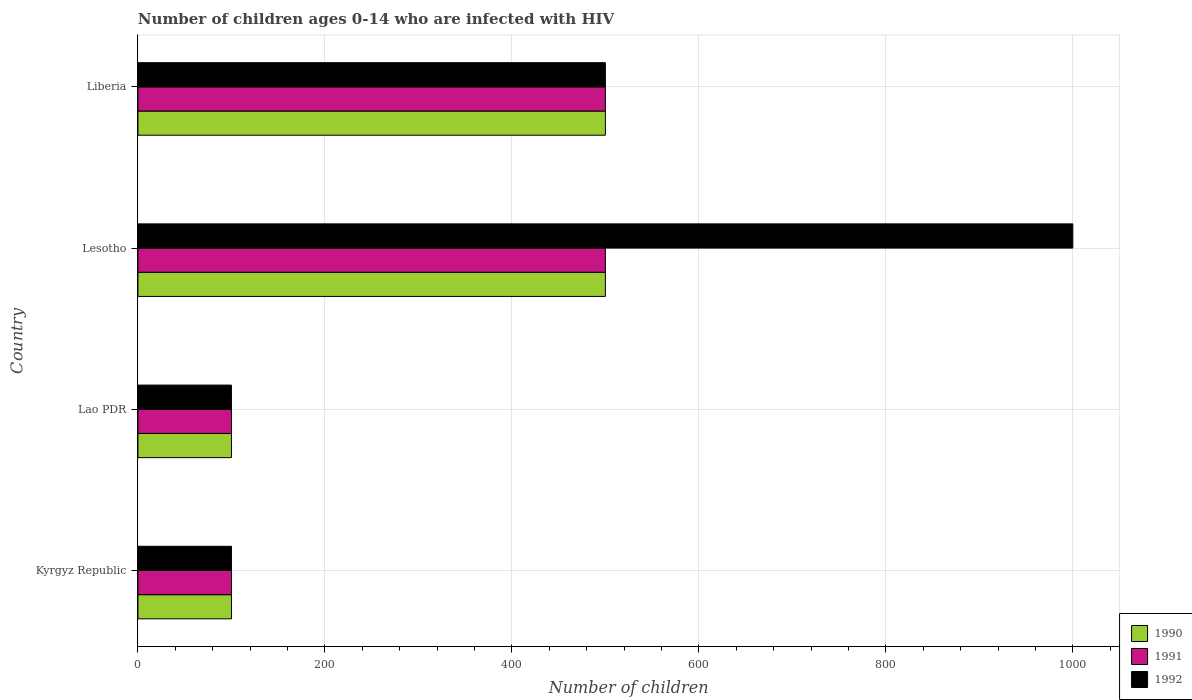How many different coloured bars are there?
Ensure brevity in your answer.  3. How many bars are there on the 2nd tick from the top?
Keep it short and to the point. 3. How many bars are there on the 2nd tick from the bottom?
Ensure brevity in your answer.  3. What is the label of the 1st group of bars from the top?
Ensure brevity in your answer.  Liberia. In how many cases, is the number of bars for a given country not equal to the number of legend labels?
Your answer should be compact. 0. What is the number of HIV infected children in 1990 in Kyrgyz Republic?
Your response must be concise. 100. Across all countries, what is the maximum number of HIV infected children in 1990?
Your answer should be very brief. 500. Across all countries, what is the minimum number of HIV infected children in 1992?
Give a very brief answer. 100. In which country was the number of HIV infected children in 1990 maximum?
Your answer should be very brief. Lesotho. In which country was the number of HIV infected children in 1991 minimum?
Make the answer very short. Kyrgyz Republic. What is the total number of HIV infected children in 1991 in the graph?
Give a very brief answer. 1200. What is the difference between the number of HIV infected children in 1992 in Kyrgyz Republic and that in Lao PDR?
Your answer should be very brief. 0. What is the difference between the number of HIV infected children in 1990 in Liberia and the number of HIV infected children in 1991 in Kyrgyz Republic?
Offer a terse response. 400. What is the average number of HIV infected children in 1992 per country?
Ensure brevity in your answer.  425. What is the difference between the number of HIV infected children in 1992 and number of HIV infected children in 1990 in Kyrgyz Republic?
Offer a very short reply. 0. What is the ratio of the number of HIV infected children in 1991 in Kyrgyz Republic to that in Liberia?
Offer a terse response. 0.2. What is the difference between the highest and the lowest number of HIV infected children in 1991?
Offer a terse response. 400. Is the sum of the number of HIV infected children in 1990 in Kyrgyz Republic and Lesotho greater than the maximum number of HIV infected children in 1991 across all countries?
Provide a succinct answer. Yes. Is it the case that in every country, the sum of the number of HIV infected children in 1992 and number of HIV infected children in 1990 is greater than the number of HIV infected children in 1991?
Your answer should be compact. Yes. Are all the bars in the graph horizontal?
Provide a short and direct response. Yes. How many countries are there in the graph?
Your response must be concise. 4. What is the difference between two consecutive major ticks on the X-axis?
Your answer should be compact. 200. Does the graph contain grids?
Your answer should be very brief. Yes. Where does the legend appear in the graph?
Your answer should be very brief. Bottom right. How many legend labels are there?
Provide a succinct answer. 3. What is the title of the graph?
Your answer should be compact. Number of children ages 0-14 who are infected with HIV. What is the label or title of the X-axis?
Your answer should be very brief. Number of children. What is the Number of children in 1990 in Kyrgyz Republic?
Ensure brevity in your answer.  100. What is the Number of children in 1990 in Lao PDR?
Offer a terse response. 100. What is the Number of children of 1992 in Lao PDR?
Provide a short and direct response. 100. What is the Number of children in 1990 in Lesotho?
Your response must be concise. 500. What is the Number of children in 1990 in Liberia?
Your response must be concise. 500. What is the Number of children of 1992 in Liberia?
Your answer should be very brief. 500. Across all countries, what is the maximum Number of children in 1991?
Offer a terse response. 500. Across all countries, what is the maximum Number of children in 1992?
Your answer should be very brief. 1000. Across all countries, what is the minimum Number of children in 1991?
Provide a succinct answer. 100. Across all countries, what is the minimum Number of children in 1992?
Make the answer very short. 100. What is the total Number of children of 1990 in the graph?
Ensure brevity in your answer.  1200. What is the total Number of children in 1991 in the graph?
Provide a short and direct response. 1200. What is the total Number of children in 1992 in the graph?
Provide a short and direct response. 1700. What is the difference between the Number of children in 1990 in Kyrgyz Republic and that in Lesotho?
Provide a succinct answer. -400. What is the difference between the Number of children in 1991 in Kyrgyz Republic and that in Lesotho?
Make the answer very short. -400. What is the difference between the Number of children in 1992 in Kyrgyz Republic and that in Lesotho?
Provide a short and direct response. -900. What is the difference between the Number of children of 1990 in Kyrgyz Republic and that in Liberia?
Your response must be concise. -400. What is the difference between the Number of children in 1991 in Kyrgyz Republic and that in Liberia?
Keep it short and to the point. -400. What is the difference between the Number of children in 1992 in Kyrgyz Republic and that in Liberia?
Make the answer very short. -400. What is the difference between the Number of children of 1990 in Lao PDR and that in Lesotho?
Provide a succinct answer. -400. What is the difference between the Number of children of 1991 in Lao PDR and that in Lesotho?
Your response must be concise. -400. What is the difference between the Number of children in 1992 in Lao PDR and that in Lesotho?
Offer a very short reply. -900. What is the difference between the Number of children of 1990 in Lao PDR and that in Liberia?
Your answer should be compact. -400. What is the difference between the Number of children of 1991 in Lao PDR and that in Liberia?
Give a very brief answer. -400. What is the difference between the Number of children in 1992 in Lao PDR and that in Liberia?
Ensure brevity in your answer.  -400. What is the difference between the Number of children in 1991 in Lesotho and that in Liberia?
Keep it short and to the point. 0. What is the difference between the Number of children in 1992 in Lesotho and that in Liberia?
Your response must be concise. 500. What is the difference between the Number of children of 1990 in Kyrgyz Republic and the Number of children of 1992 in Lao PDR?
Ensure brevity in your answer.  0. What is the difference between the Number of children in 1990 in Kyrgyz Republic and the Number of children in 1991 in Lesotho?
Keep it short and to the point. -400. What is the difference between the Number of children of 1990 in Kyrgyz Republic and the Number of children of 1992 in Lesotho?
Give a very brief answer. -900. What is the difference between the Number of children in 1991 in Kyrgyz Republic and the Number of children in 1992 in Lesotho?
Ensure brevity in your answer.  -900. What is the difference between the Number of children of 1990 in Kyrgyz Republic and the Number of children of 1991 in Liberia?
Provide a succinct answer. -400. What is the difference between the Number of children in 1990 in Kyrgyz Republic and the Number of children in 1992 in Liberia?
Ensure brevity in your answer.  -400. What is the difference between the Number of children in 1991 in Kyrgyz Republic and the Number of children in 1992 in Liberia?
Your answer should be very brief. -400. What is the difference between the Number of children of 1990 in Lao PDR and the Number of children of 1991 in Lesotho?
Your answer should be very brief. -400. What is the difference between the Number of children in 1990 in Lao PDR and the Number of children in 1992 in Lesotho?
Your response must be concise. -900. What is the difference between the Number of children in 1991 in Lao PDR and the Number of children in 1992 in Lesotho?
Ensure brevity in your answer.  -900. What is the difference between the Number of children of 1990 in Lao PDR and the Number of children of 1991 in Liberia?
Your answer should be very brief. -400. What is the difference between the Number of children of 1990 in Lao PDR and the Number of children of 1992 in Liberia?
Offer a terse response. -400. What is the difference between the Number of children of 1991 in Lao PDR and the Number of children of 1992 in Liberia?
Offer a terse response. -400. What is the difference between the Number of children in 1990 in Lesotho and the Number of children in 1992 in Liberia?
Offer a very short reply. 0. What is the average Number of children in 1990 per country?
Ensure brevity in your answer.  300. What is the average Number of children in 1991 per country?
Your response must be concise. 300. What is the average Number of children of 1992 per country?
Provide a short and direct response. 425. What is the difference between the Number of children of 1990 and Number of children of 1991 in Kyrgyz Republic?
Provide a short and direct response. 0. What is the difference between the Number of children in 1990 and Number of children in 1992 in Lao PDR?
Offer a terse response. 0. What is the difference between the Number of children of 1991 and Number of children of 1992 in Lao PDR?
Make the answer very short. 0. What is the difference between the Number of children in 1990 and Number of children in 1991 in Lesotho?
Ensure brevity in your answer.  0. What is the difference between the Number of children in 1990 and Number of children in 1992 in Lesotho?
Offer a terse response. -500. What is the difference between the Number of children in 1991 and Number of children in 1992 in Lesotho?
Give a very brief answer. -500. What is the difference between the Number of children in 1991 and Number of children in 1992 in Liberia?
Offer a terse response. 0. What is the ratio of the Number of children in 1991 in Kyrgyz Republic to that in Lao PDR?
Give a very brief answer. 1. What is the ratio of the Number of children in 1992 in Kyrgyz Republic to that in Lao PDR?
Provide a succinct answer. 1. What is the ratio of the Number of children in 1990 in Kyrgyz Republic to that in Lesotho?
Provide a succinct answer. 0.2. What is the ratio of the Number of children in 1991 in Kyrgyz Republic to that in Lesotho?
Ensure brevity in your answer.  0.2. What is the ratio of the Number of children of 1990 in Kyrgyz Republic to that in Liberia?
Make the answer very short. 0.2. What is the ratio of the Number of children of 1991 in Kyrgyz Republic to that in Liberia?
Give a very brief answer. 0.2. What is the ratio of the Number of children of 1992 in Kyrgyz Republic to that in Liberia?
Offer a very short reply. 0.2. What is the ratio of the Number of children in 1990 in Lao PDR to that in Lesotho?
Provide a succinct answer. 0.2. What is the ratio of the Number of children in 1991 in Lao PDR to that in Lesotho?
Provide a short and direct response. 0.2. What is the ratio of the Number of children in 1990 in Lao PDR to that in Liberia?
Offer a terse response. 0.2. What is the ratio of the Number of children of 1991 in Lao PDR to that in Liberia?
Provide a succinct answer. 0.2. What is the ratio of the Number of children in 1990 in Lesotho to that in Liberia?
Ensure brevity in your answer.  1. What is the ratio of the Number of children of 1991 in Lesotho to that in Liberia?
Offer a very short reply. 1. What is the ratio of the Number of children of 1992 in Lesotho to that in Liberia?
Your answer should be compact. 2. What is the difference between the highest and the second highest Number of children in 1990?
Ensure brevity in your answer.  0. What is the difference between the highest and the lowest Number of children of 1991?
Provide a short and direct response. 400. What is the difference between the highest and the lowest Number of children in 1992?
Provide a short and direct response. 900. 